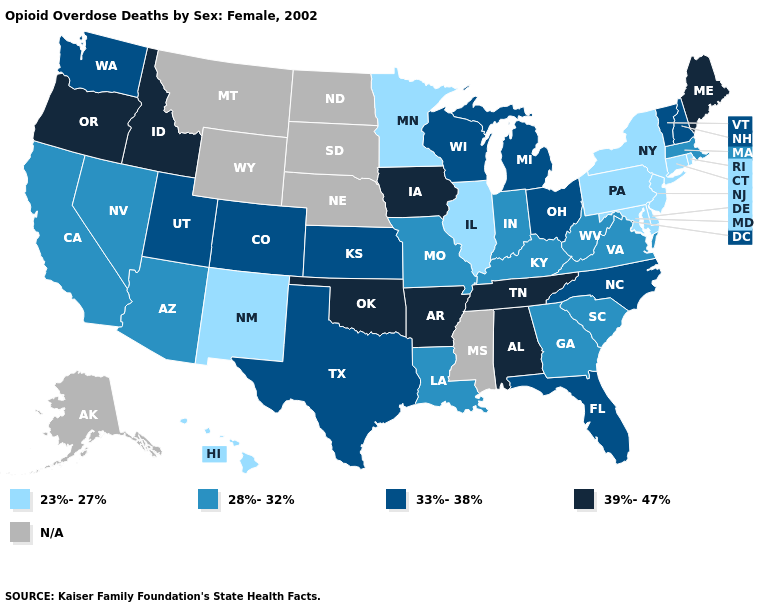Which states have the highest value in the USA?
Answer briefly. Alabama, Arkansas, Idaho, Iowa, Maine, Oklahoma, Oregon, Tennessee. What is the value of Oregon?
Quick response, please. 39%-47%. What is the value of Iowa?
Write a very short answer. 39%-47%. Does Oklahoma have the highest value in the USA?
Quick response, please. Yes. Is the legend a continuous bar?
Write a very short answer. No. How many symbols are there in the legend?
Give a very brief answer. 5. Among the states that border Nevada , which have the highest value?
Short answer required. Idaho, Oregon. What is the value of New York?
Keep it brief. 23%-27%. Name the states that have a value in the range 33%-38%?
Write a very short answer. Colorado, Florida, Kansas, Michigan, New Hampshire, North Carolina, Ohio, Texas, Utah, Vermont, Washington, Wisconsin. Does Wisconsin have the highest value in the MidWest?
Be succinct. No. What is the highest value in states that border Colorado?
Answer briefly. 39%-47%. Among the states that border West Virginia , does Virginia have the lowest value?
Concise answer only. No. What is the lowest value in states that border Colorado?
Give a very brief answer. 23%-27%. Does the first symbol in the legend represent the smallest category?
Answer briefly. Yes. Among the states that border Maryland , does Virginia have the highest value?
Give a very brief answer. Yes. 